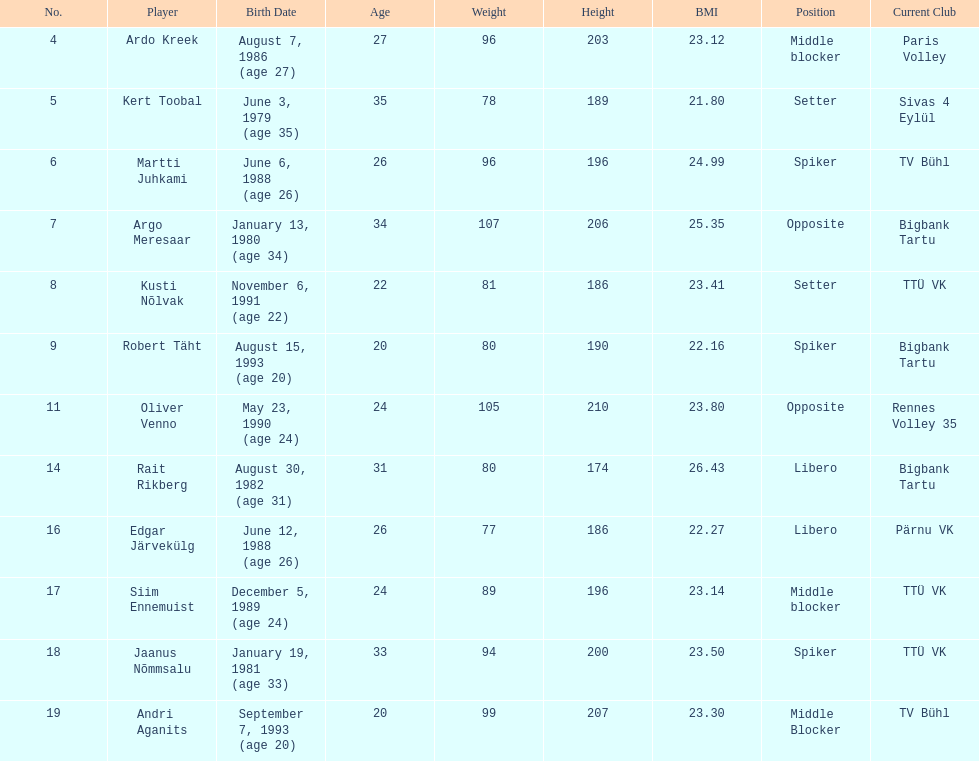What are the total number of players from france? 2. 